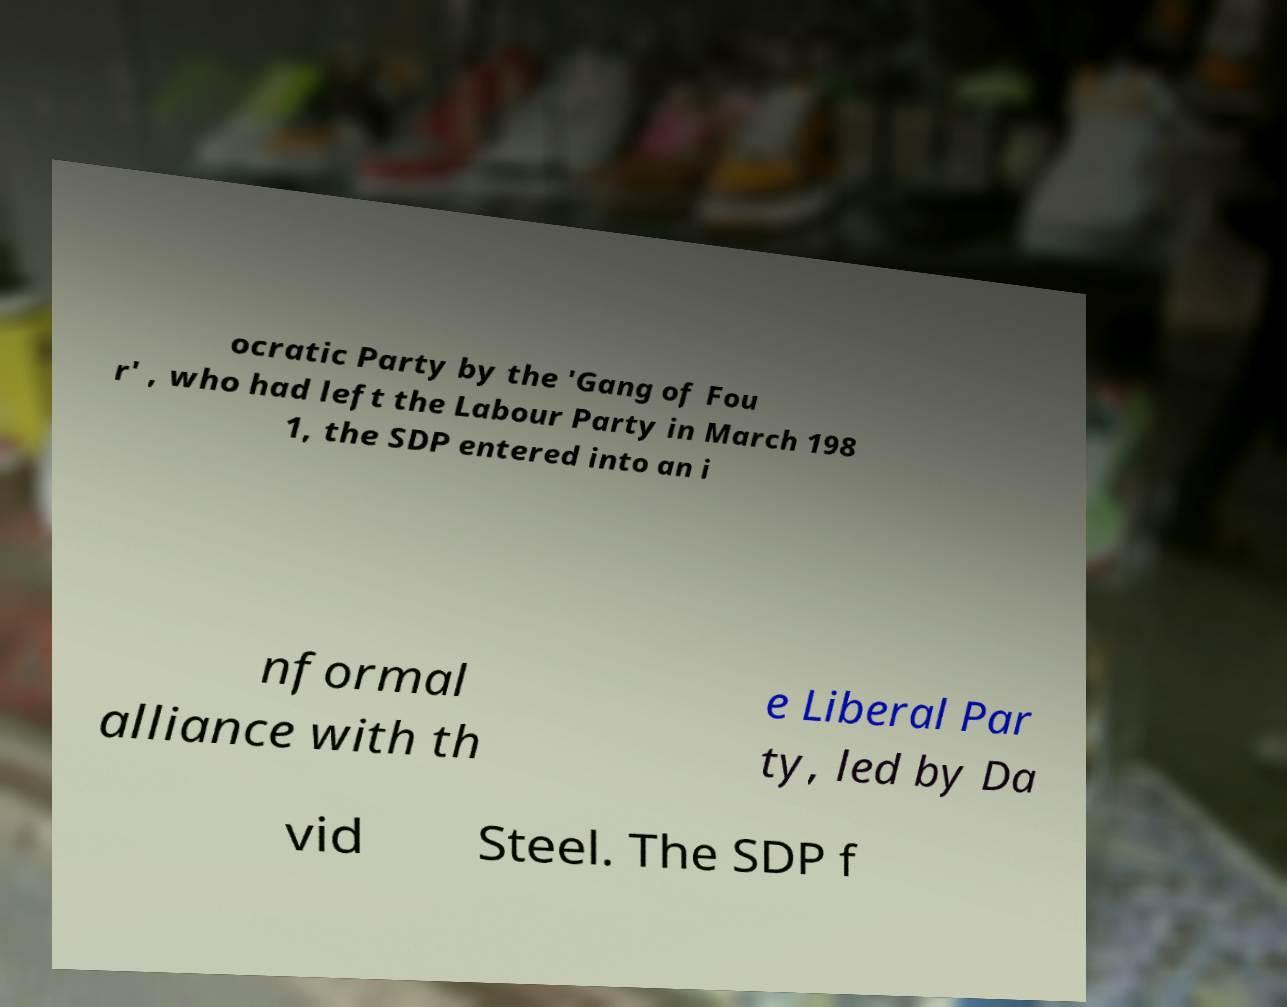Could you assist in decoding the text presented in this image and type it out clearly? ocratic Party by the 'Gang of Fou r' , who had left the Labour Party in March 198 1, the SDP entered into an i nformal alliance with th e Liberal Par ty, led by Da vid Steel. The SDP f 